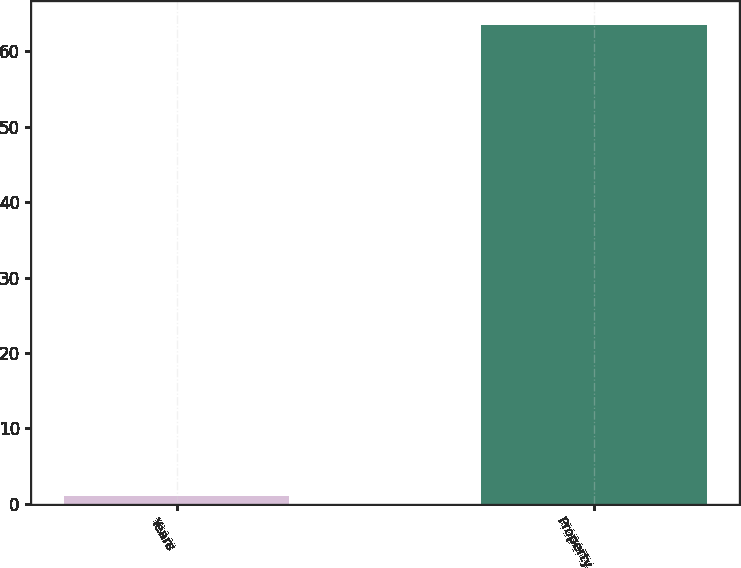<chart> <loc_0><loc_0><loc_500><loc_500><bar_chart><fcel>Years<fcel>Property<nl><fcel>1<fcel>63.5<nl></chart> 